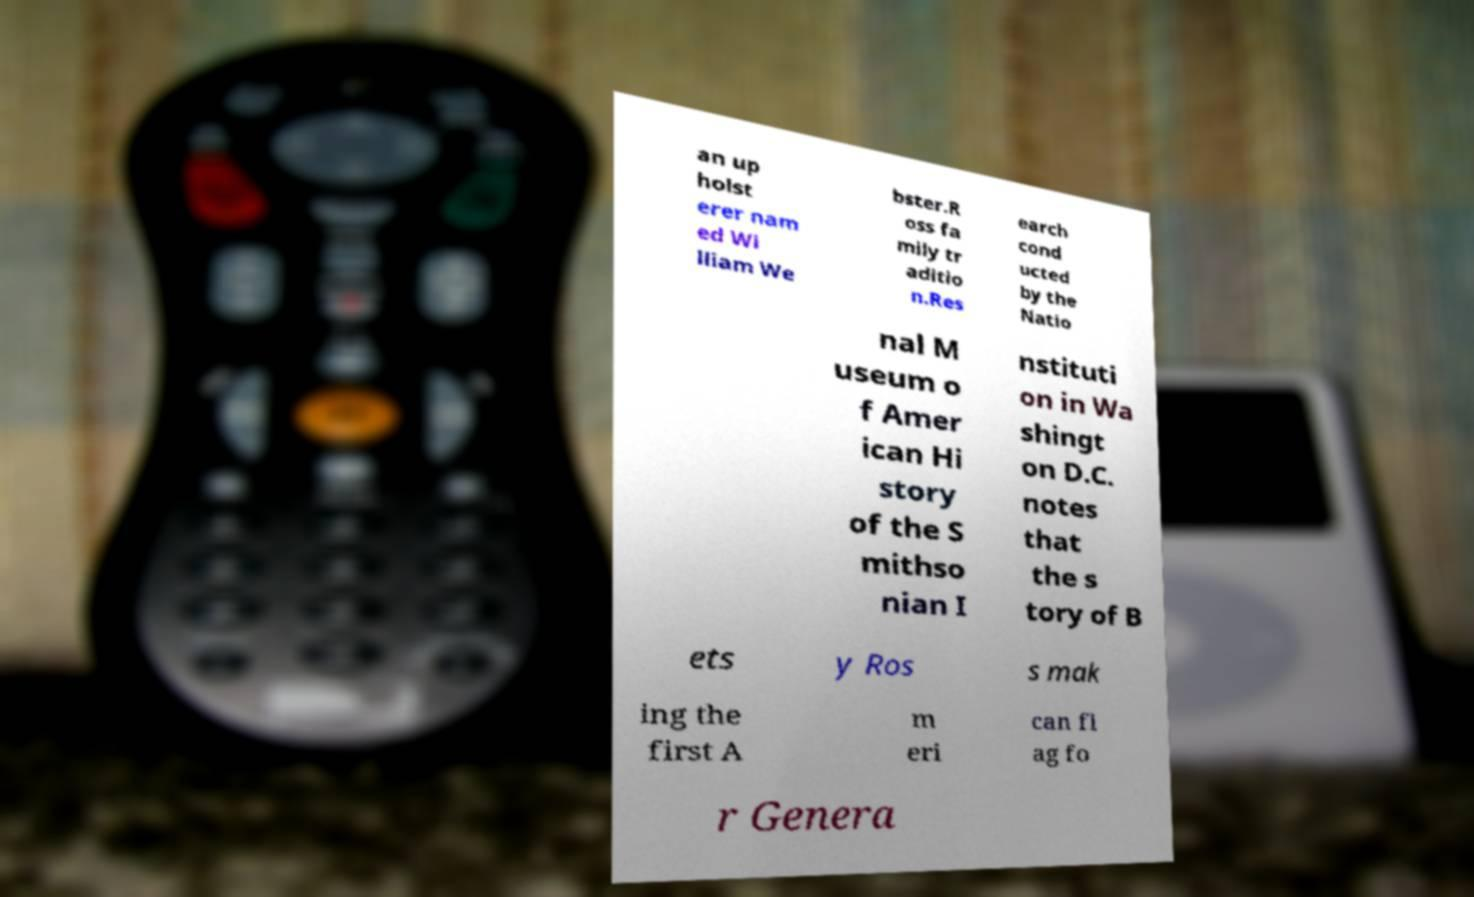There's text embedded in this image that I need extracted. Can you transcribe it verbatim? an up holst erer nam ed Wi lliam We bster.R oss fa mily tr aditio n.Res earch cond ucted by the Natio nal M useum o f Amer ican Hi story of the S mithso nian I nstituti on in Wa shingt on D.C. notes that the s tory of B ets y Ros s mak ing the first A m eri can fl ag fo r Genera 